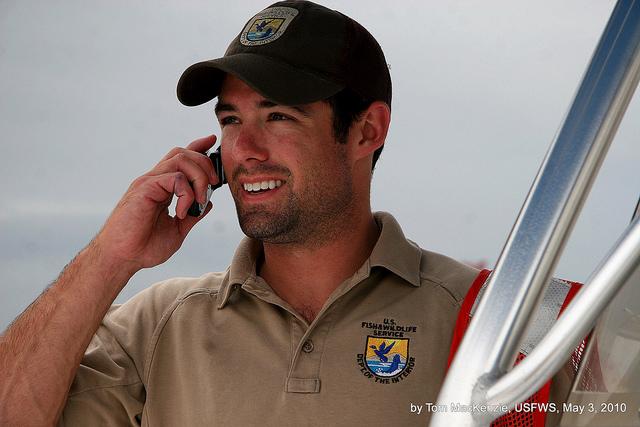What color is his hat?
Quick response, please. Black. Is he talking on his phone?
Short answer required. Yes. Is he sad?
Short answer required. No. 